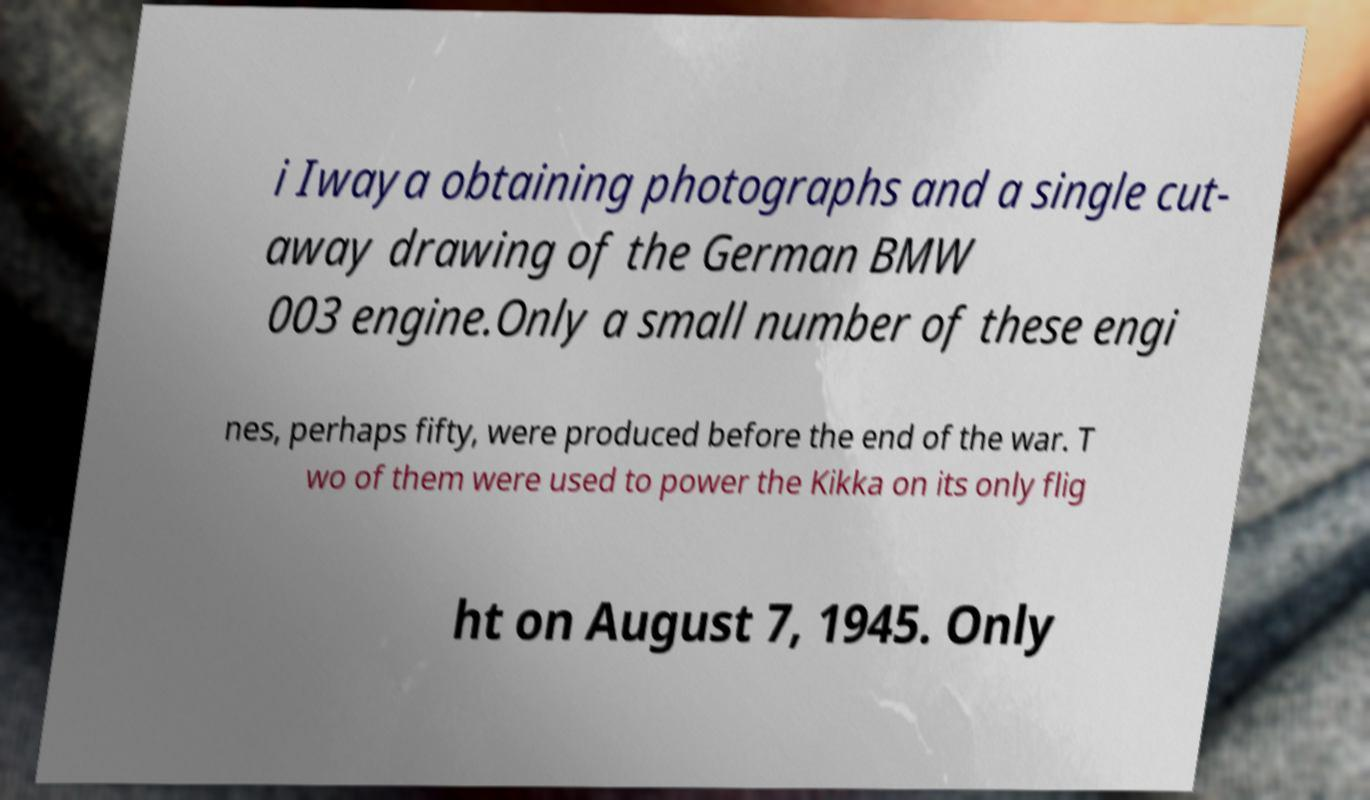Could you assist in decoding the text presented in this image and type it out clearly? i Iwaya obtaining photographs and a single cut- away drawing of the German BMW 003 engine.Only a small number of these engi nes, perhaps fifty, were produced before the end of the war. T wo of them were used to power the Kikka on its only flig ht on August 7, 1945. Only 